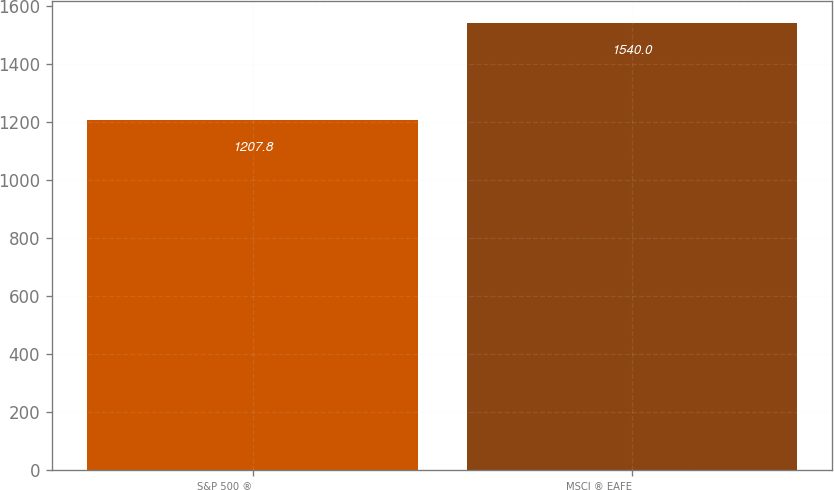Convert chart. <chart><loc_0><loc_0><loc_500><loc_500><bar_chart><fcel>S&P 500 ®<fcel>MSCI ® EAFE<nl><fcel>1207.8<fcel>1540<nl></chart> 